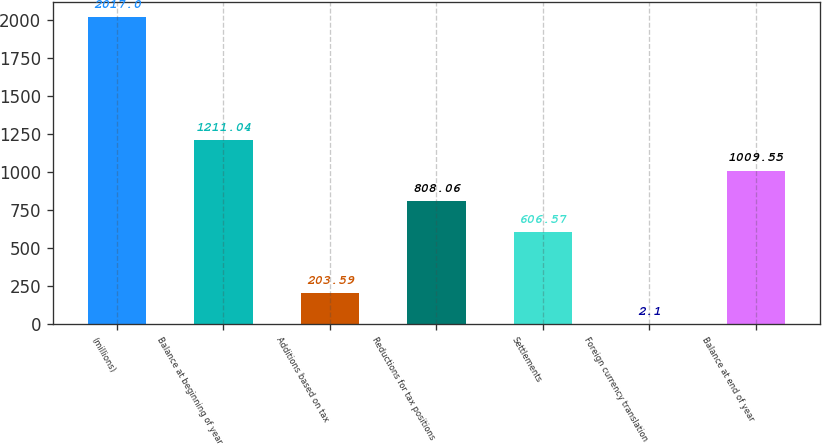<chart> <loc_0><loc_0><loc_500><loc_500><bar_chart><fcel>(millions)<fcel>Balance at beginning of year<fcel>Additions based on tax<fcel>Reductions for tax positions<fcel>Settlements<fcel>Foreign currency translation<fcel>Balance at end of year<nl><fcel>2017<fcel>1211.04<fcel>203.59<fcel>808.06<fcel>606.57<fcel>2.1<fcel>1009.55<nl></chart> 